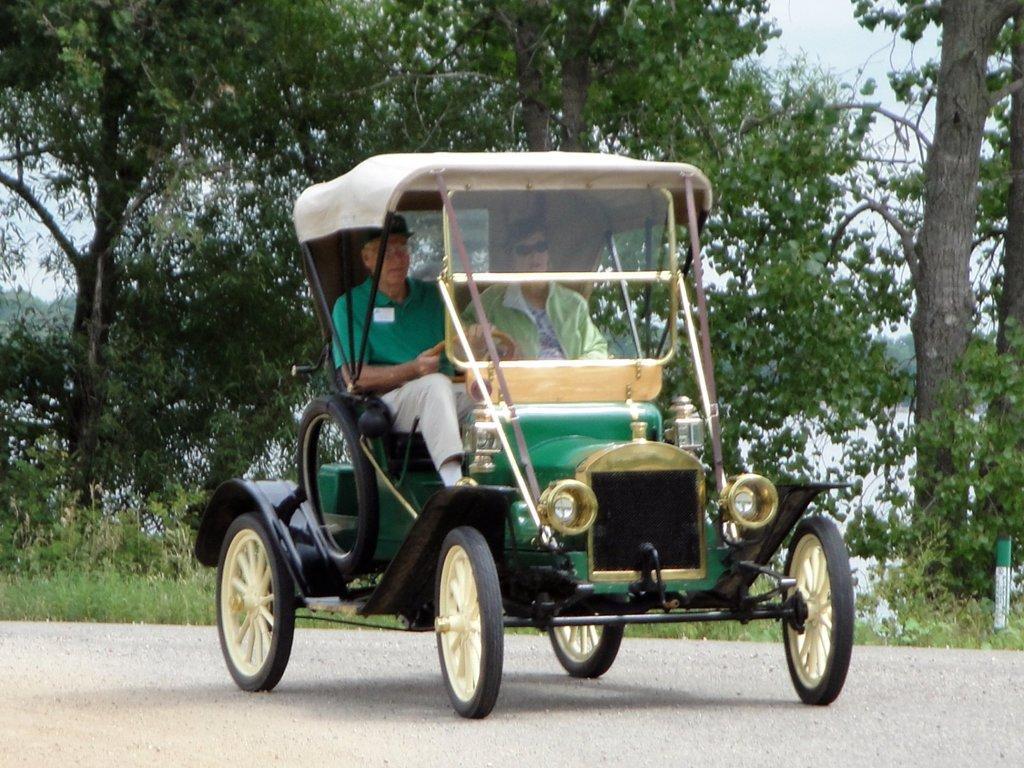Can you describe this image briefly? Here I can see a vehicle on the road. Inside the vehicle two men are sitting. In the background, I can see the trees. 